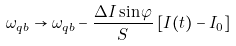<formula> <loc_0><loc_0><loc_500><loc_500>\omega _ { q b } \rightarrow \omega _ { q b } - \frac { \Delta I \sin \varphi } { S } \, [ I ( t ) - I _ { 0 } ]</formula> 